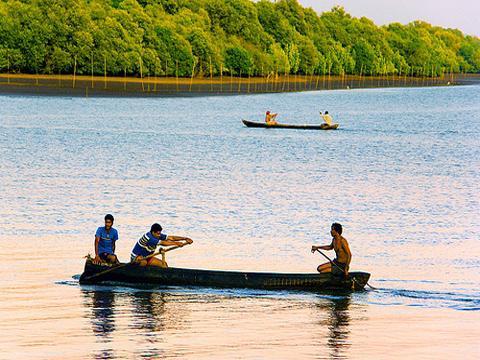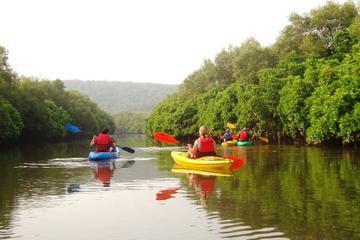The first image is the image on the left, the second image is the image on the right. For the images shown, is this caption "An image includes three people in one canoe on the water." true? Answer yes or no. Yes. The first image is the image on the left, the second image is the image on the right. Assess this claim about the two images: "In one image, three people, two of them using or sitting near oars, can be seen in a single canoe in a body of water near a shoreline with trees,". Correct or not? Answer yes or no. Yes. 